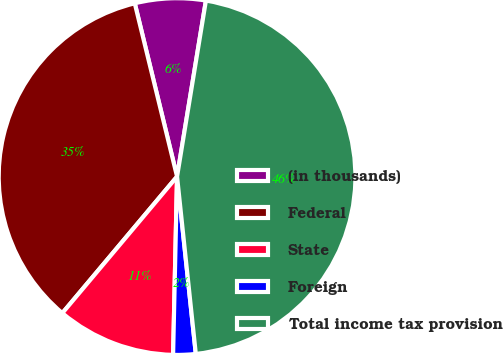Convert chart to OTSL. <chart><loc_0><loc_0><loc_500><loc_500><pie_chart><fcel>(in thousands)<fcel>Federal<fcel>State<fcel>Foreign<fcel>Total income tax provision<nl><fcel>6.4%<fcel>35.07%<fcel>10.77%<fcel>2.03%<fcel>45.74%<nl></chart> 